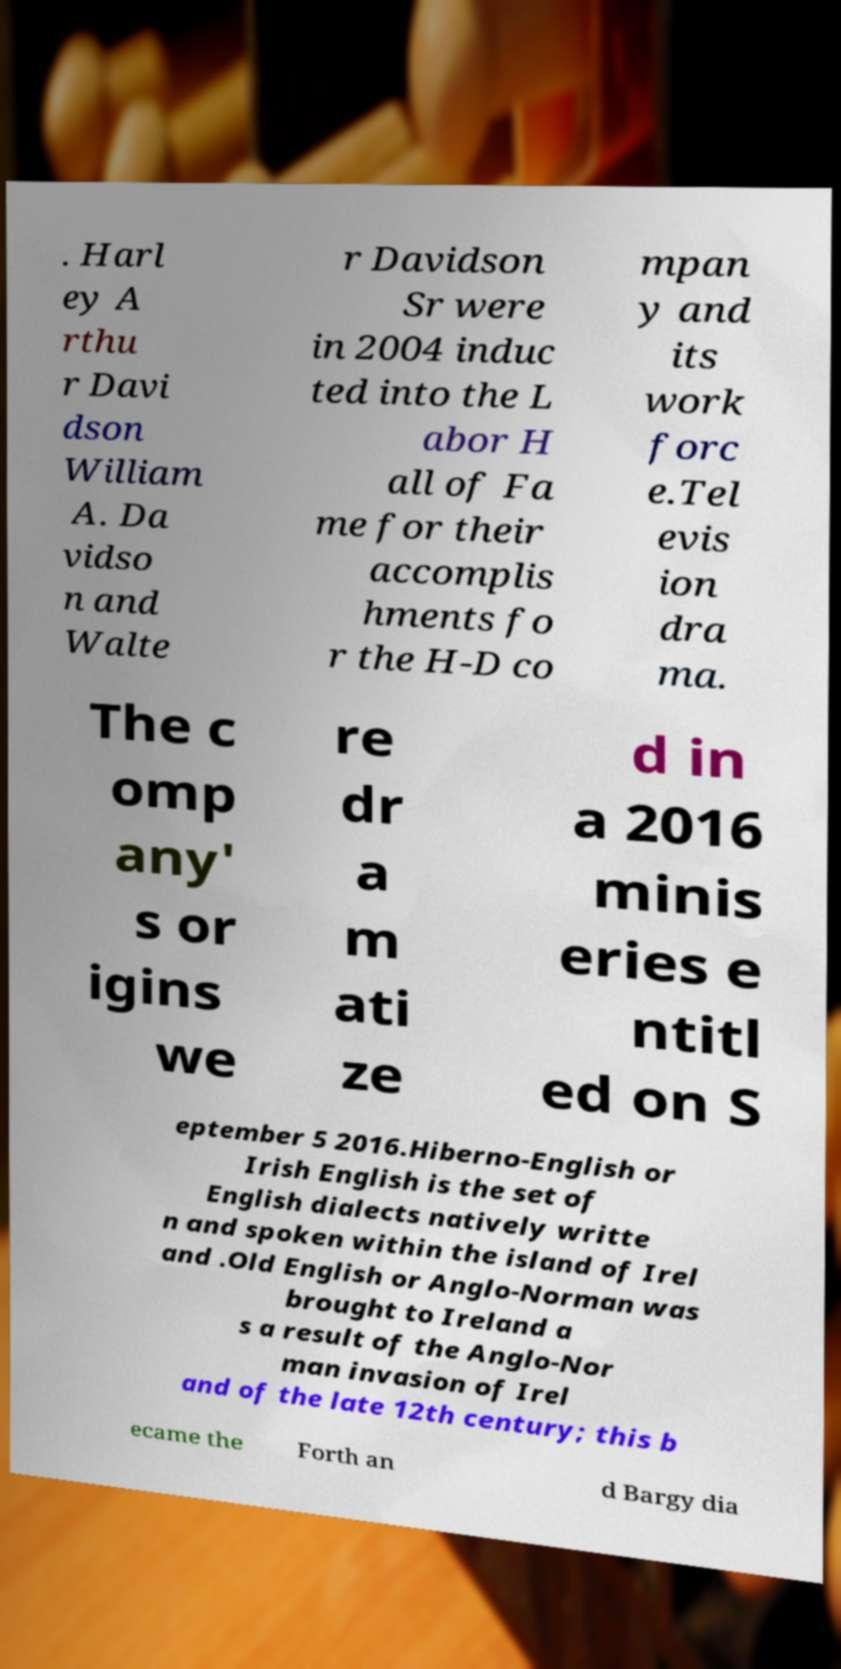Please identify and transcribe the text found in this image. . Harl ey A rthu r Davi dson William A. Da vidso n and Walte r Davidson Sr were in 2004 induc ted into the L abor H all of Fa me for their accomplis hments fo r the H-D co mpan y and its work forc e.Tel evis ion dra ma. The c omp any' s or igins we re dr a m ati ze d in a 2016 minis eries e ntitl ed on S eptember 5 2016.Hiberno-English or Irish English is the set of English dialects natively writte n and spoken within the island of Irel and .Old English or Anglo-Norman was brought to Ireland a s a result of the Anglo-Nor man invasion of Irel and of the late 12th century; this b ecame the Forth an d Bargy dia 